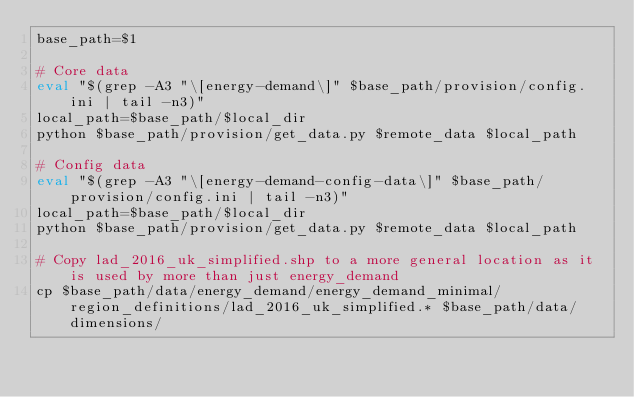Convert code to text. <code><loc_0><loc_0><loc_500><loc_500><_Bash_>base_path=$1

# Core data
eval "$(grep -A3 "\[energy-demand\]" $base_path/provision/config.ini | tail -n3)"
local_path=$base_path/$local_dir
python $base_path/provision/get_data.py $remote_data $local_path

# Config data
eval "$(grep -A3 "\[energy-demand-config-data\]" $base_path/provision/config.ini | tail -n3)"
local_path=$base_path/$local_dir
python $base_path/provision/get_data.py $remote_data $local_path

# Copy lad_2016_uk_simplified.shp to a more general location as it is used by more than just energy_demand
cp $base_path/data/energy_demand/energy_demand_minimal/region_definitions/lad_2016_uk_simplified.* $base_path/data/dimensions/
</code> 